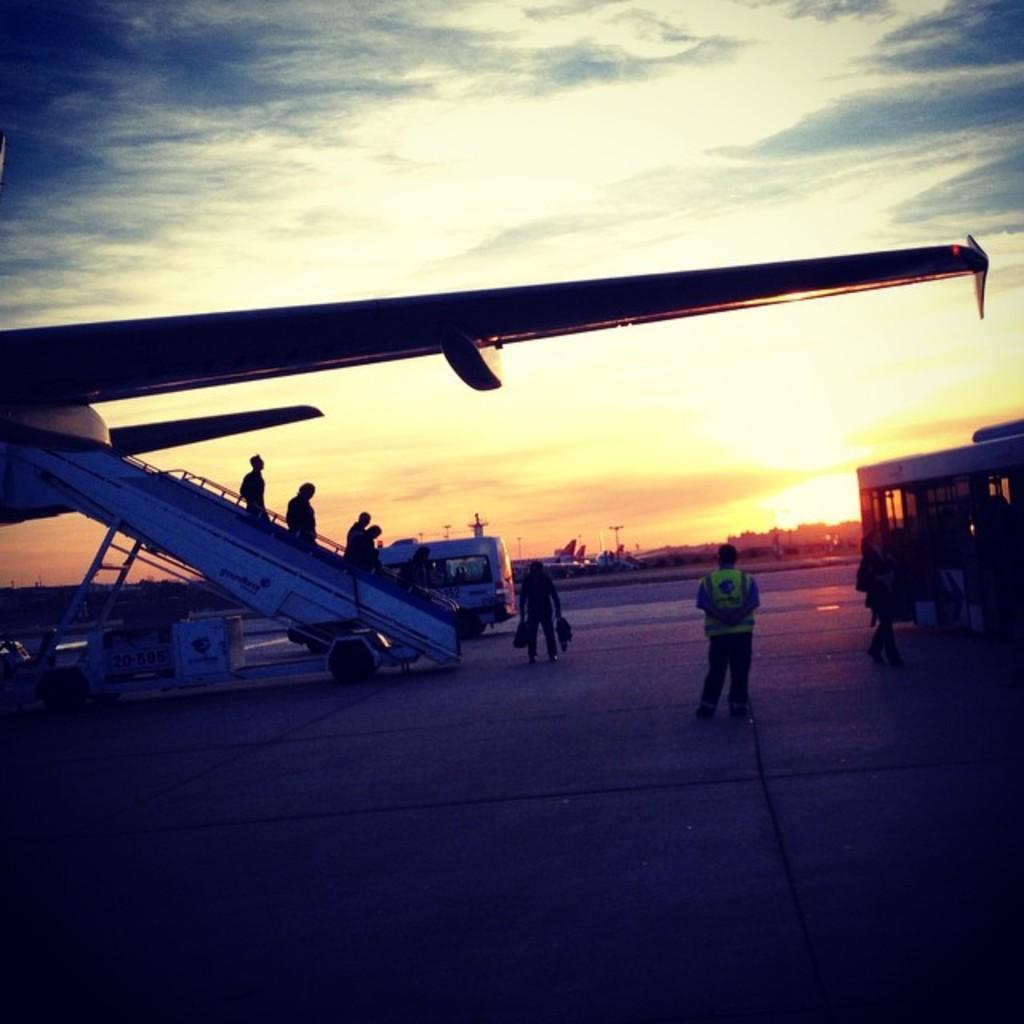In one or two sentences, can you explain what this image depicts? In this image I can see an airplane's wing and under it I can see number of people are standing. I can also see a vehicle in the background and few other things. On the right side of this image I can see one more vehicle. I can also see clouds, the sky and the sun in the background. 